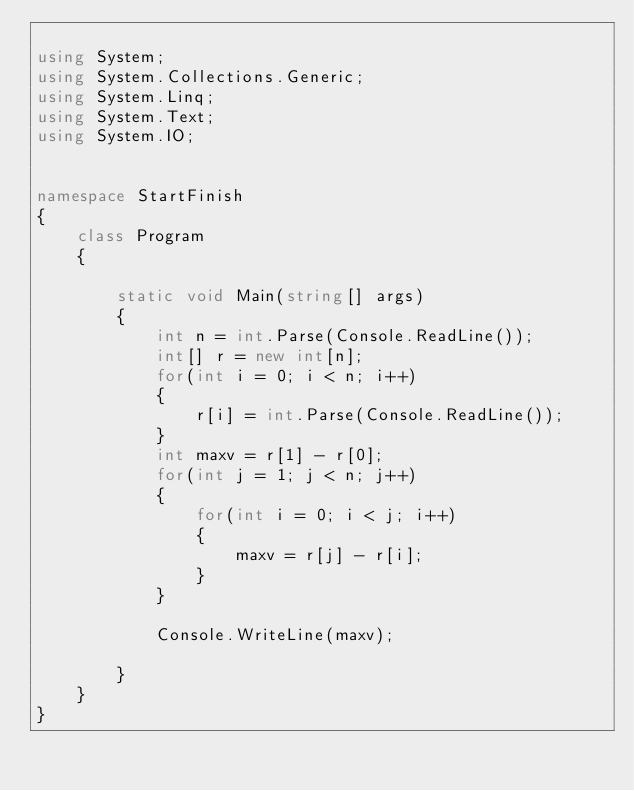<code> <loc_0><loc_0><loc_500><loc_500><_C#_>
using System;
using System.Collections.Generic;
using System.Linq;
using System.Text;
using System.IO;


namespace StartFinish
{
    class Program
    {   
            
        static void Main(string[] args)
        {
            int n = int.Parse(Console.ReadLine());
            int[] r = new int[n];
            for(int i = 0; i < n; i++)
            {
                r[i] = int.Parse(Console.ReadLine());
            }
            int maxv = r[1] - r[0];
            for(int j = 1; j < n; j++)
            {
                for(int i = 0; i < j; i++)
                {
                    maxv = r[j] - r[i];
                }
            }

            Console.WriteLine(maxv);
            
        }
    }
}</code> 